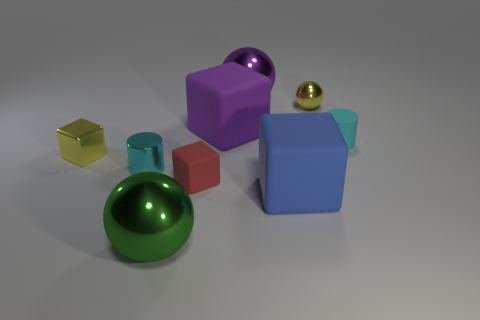There is a tiny cyan cylinder that is on the right side of the metal sphere that is in front of the tiny cyan cylinder that is in front of the tiny rubber cylinder; what is its material?
Offer a very short reply. Rubber. There is a big metal sphere that is in front of the cyan object that is on the right side of the green metal sphere; what is its color?
Offer a very short reply. Green. What number of tiny things are red blocks or gray cubes?
Your response must be concise. 1. What number of large red cubes are made of the same material as the blue cube?
Give a very brief answer. 0. There is a cyan thing to the right of the small metallic cylinder; how big is it?
Provide a succinct answer. Small. There is a large rubber object that is in front of the small cyan thing right of the red object; what is its shape?
Keep it short and to the point. Cube. There is a cyan object left of the cylinder right of the large blue matte cube; how many large blue blocks are to the right of it?
Offer a very short reply. 1. Is the number of blue matte objects that are left of the purple shiny object less than the number of purple metallic things?
Provide a succinct answer. Yes. Is there anything else that is the same shape as the large purple metallic thing?
Provide a succinct answer. Yes. There is a small cyan object on the left side of the green metal sphere; what is its shape?
Ensure brevity in your answer.  Cylinder. 